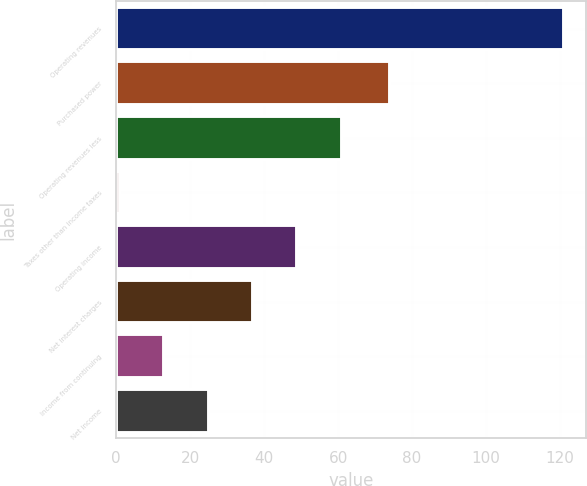Convert chart. <chart><loc_0><loc_0><loc_500><loc_500><bar_chart><fcel>Operating revenues<fcel>Purchased power<fcel>Operating revenues less<fcel>Taxes other than income taxes<fcel>Operating income<fcel>Net interest charges<fcel>Income from continuing<fcel>Net income<nl><fcel>121<fcel>74<fcel>61<fcel>1<fcel>49<fcel>37<fcel>13<fcel>25<nl></chart> 